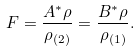Convert formula to latex. <formula><loc_0><loc_0><loc_500><loc_500>F = \frac { A ^ { * } \rho } { \rho _ { ( 2 ) } } = \frac { B ^ { * } \rho } { \rho _ { ( 1 ) } } .</formula> 